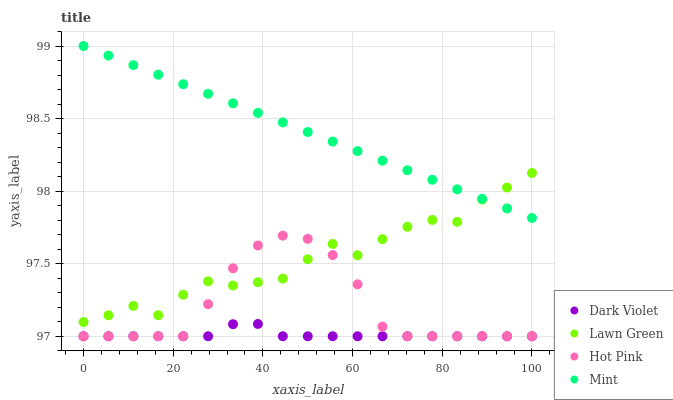Does Dark Violet have the minimum area under the curve?
Answer yes or no. Yes. Does Mint have the maximum area under the curve?
Answer yes or no. Yes. Does Hot Pink have the minimum area under the curve?
Answer yes or no. No. Does Hot Pink have the maximum area under the curve?
Answer yes or no. No. Is Mint the smoothest?
Answer yes or no. Yes. Is Lawn Green the roughest?
Answer yes or no. Yes. Is Hot Pink the smoothest?
Answer yes or no. No. Is Hot Pink the roughest?
Answer yes or no. No. Does Hot Pink have the lowest value?
Answer yes or no. Yes. Does Mint have the lowest value?
Answer yes or no. No. Does Mint have the highest value?
Answer yes or no. Yes. Does Hot Pink have the highest value?
Answer yes or no. No. Is Dark Violet less than Lawn Green?
Answer yes or no. Yes. Is Lawn Green greater than Dark Violet?
Answer yes or no. Yes. Does Hot Pink intersect Dark Violet?
Answer yes or no. Yes. Is Hot Pink less than Dark Violet?
Answer yes or no. No. Is Hot Pink greater than Dark Violet?
Answer yes or no. No. Does Dark Violet intersect Lawn Green?
Answer yes or no. No. 